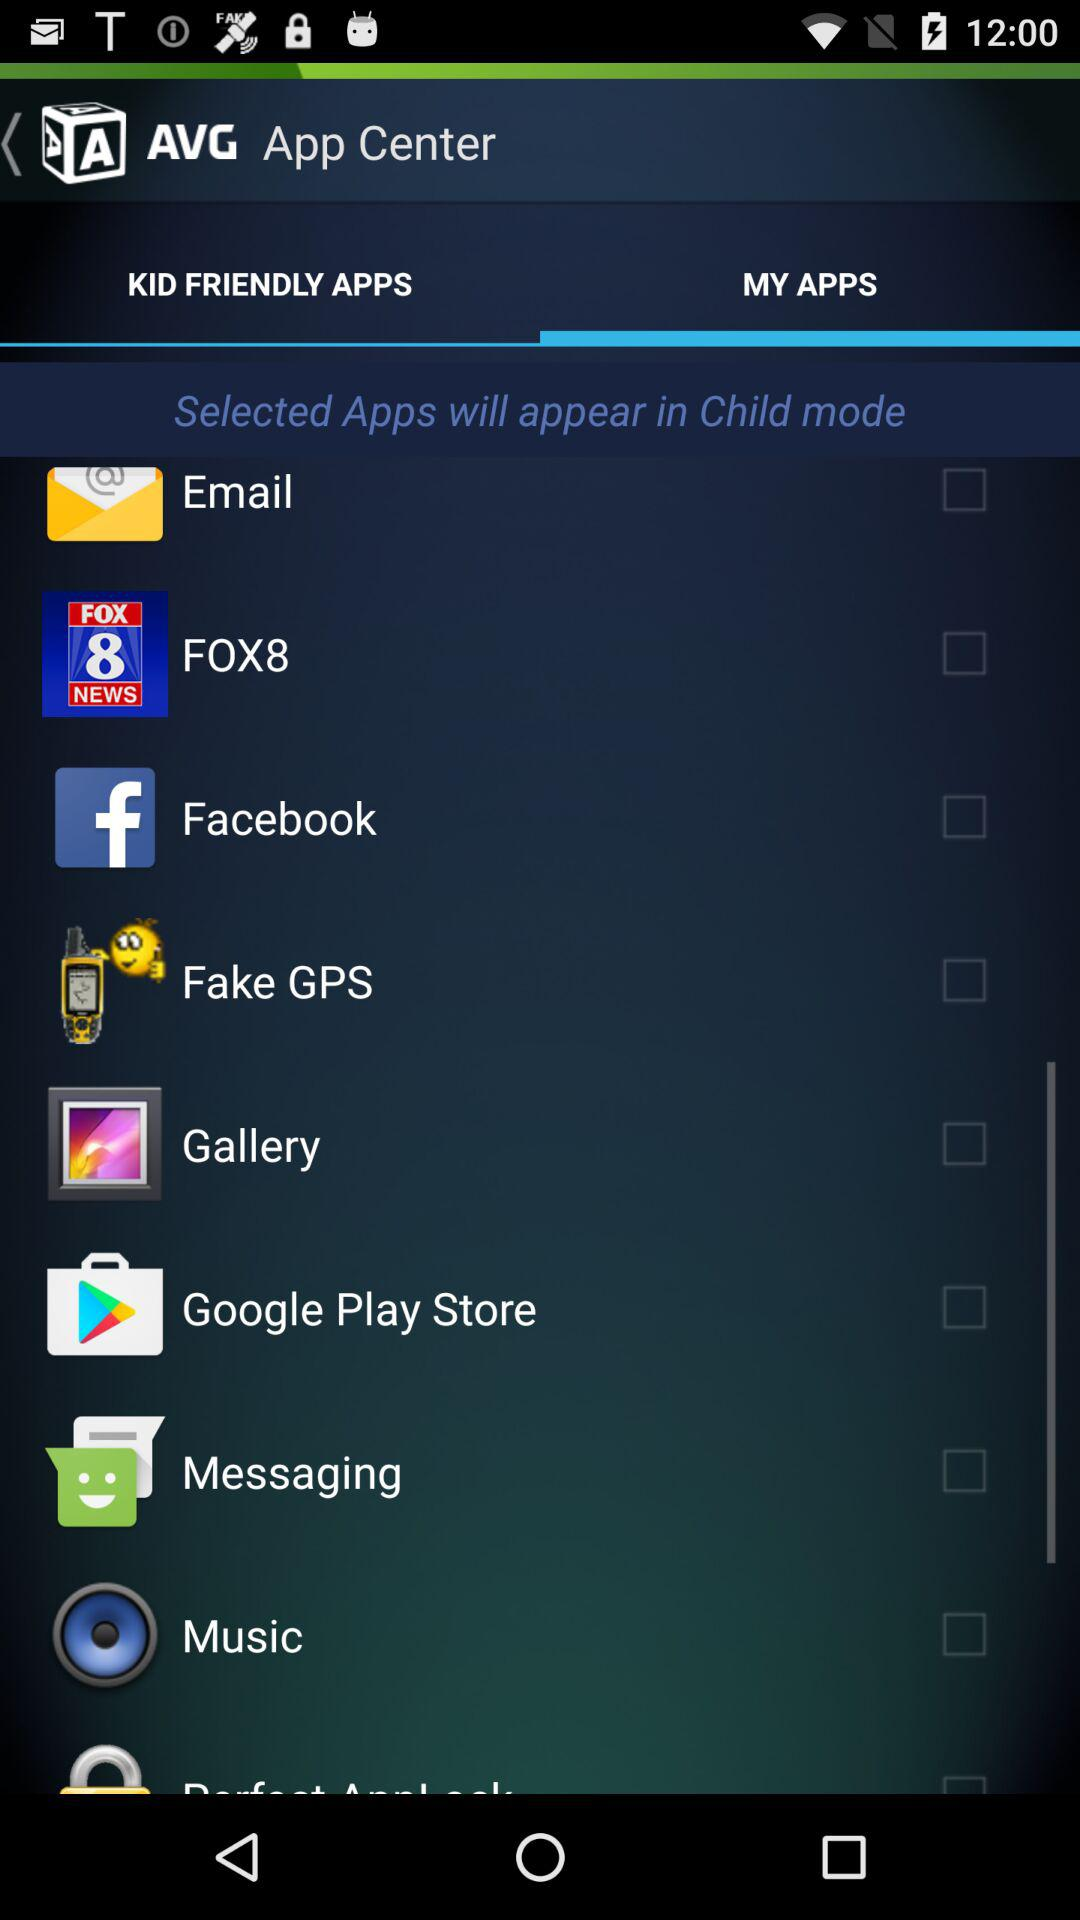Which tab is selected? The selected tab is "MY APPS". 